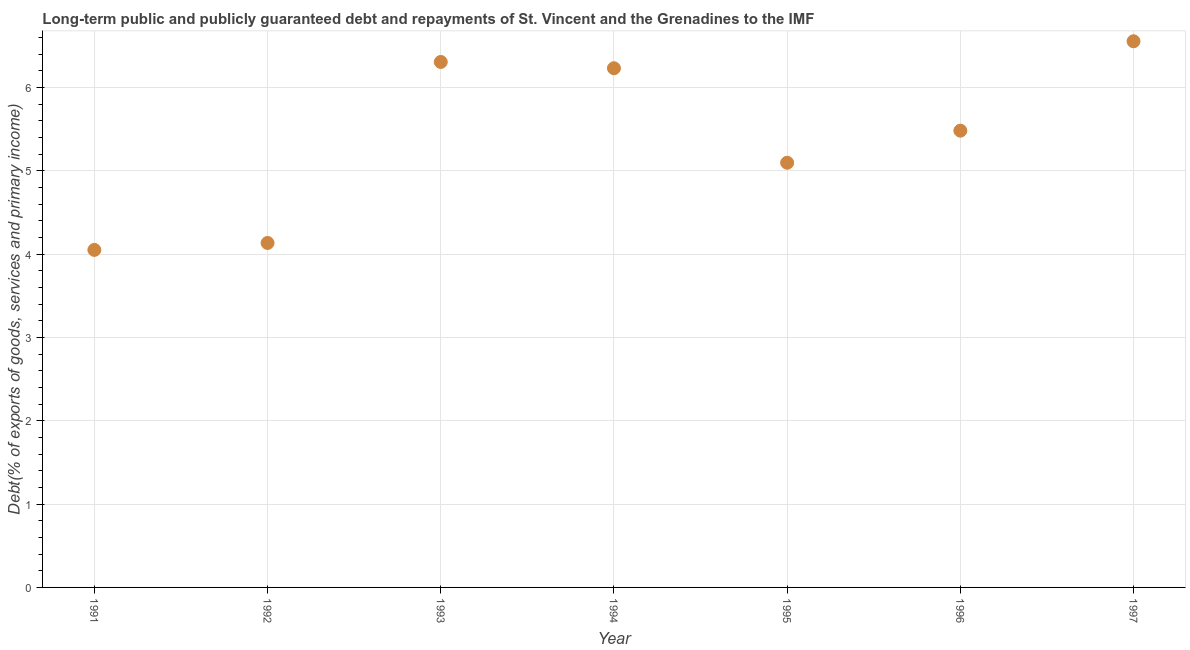What is the debt service in 1992?
Provide a succinct answer. 4.13. Across all years, what is the maximum debt service?
Provide a short and direct response. 6.55. Across all years, what is the minimum debt service?
Your answer should be compact. 4.05. In which year was the debt service maximum?
Provide a succinct answer. 1997. In which year was the debt service minimum?
Ensure brevity in your answer.  1991. What is the sum of the debt service?
Provide a succinct answer. 37.85. What is the difference between the debt service in 1994 and 1995?
Your response must be concise. 1.13. What is the average debt service per year?
Provide a succinct answer. 5.41. What is the median debt service?
Ensure brevity in your answer.  5.48. In how many years, is the debt service greater than 6.4 %?
Your response must be concise. 1. What is the ratio of the debt service in 1994 to that in 1995?
Provide a succinct answer. 1.22. Is the debt service in 1996 less than that in 1997?
Offer a very short reply. Yes. Is the difference between the debt service in 1996 and 1997 greater than the difference between any two years?
Offer a very short reply. No. What is the difference between the highest and the second highest debt service?
Provide a short and direct response. 0.25. What is the difference between the highest and the lowest debt service?
Ensure brevity in your answer.  2.5. In how many years, is the debt service greater than the average debt service taken over all years?
Your answer should be very brief. 4. Does the debt service monotonically increase over the years?
Keep it short and to the point. No. Are the values on the major ticks of Y-axis written in scientific E-notation?
Give a very brief answer. No. Does the graph contain any zero values?
Ensure brevity in your answer.  No. Does the graph contain grids?
Make the answer very short. Yes. What is the title of the graph?
Provide a succinct answer. Long-term public and publicly guaranteed debt and repayments of St. Vincent and the Grenadines to the IMF. What is the label or title of the Y-axis?
Provide a short and direct response. Debt(% of exports of goods, services and primary income). What is the Debt(% of exports of goods, services and primary income) in 1991?
Provide a succinct answer. 4.05. What is the Debt(% of exports of goods, services and primary income) in 1992?
Your answer should be very brief. 4.13. What is the Debt(% of exports of goods, services and primary income) in 1993?
Offer a very short reply. 6.31. What is the Debt(% of exports of goods, services and primary income) in 1994?
Offer a terse response. 6.23. What is the Debt(% of exports of goods, services and primary income) in 1995?
Your response must be concise. 5.1. What is the Debt(% of exports of goods, services and primary income) in 1996?
Your answer should be compact. 5.48. What is the Debt(% of exports of goods, services and primary income) in 1997?
Your answer should be compact. 6.55. What is the difference between the Debt(% of exports of goods, services and primary income) in 1991 and 1992?
Your answer should be compact. -0.08. What is the difference between the Debt(% of exports of goods, services and primary income) in 1991 and 1993?
Offer a terse response. -2.26. What is the difference between the Debt(% of exports of goods, services and primary income) in 1991 and 1994?
Provide a short and direct response. -2.18. What is the difference between the Debt(% of exports of goods, services and primary income) in 1991 and 1995?
Make the answer very short. -1.05. What is the difference between the Debt(% of exports of goods, services and primary income) in 1991 and 1996?
Keep it short and to the point. -1.43. What is the difference between the Debt(% of exports of goods, services and primary income) in 1991 and 1997?
Ensure brevity in your answer.  -2.5. What is the difference between the Debt(% of exports of goods, services and primary income) in 1992 and 1993?
Your answer should be very brief. -2.17. What is the difference between the Debt(% of exports of goods, services and primary income) in 1992 and 1994?
Provide a short and direct response. -2.1. What is the difference between the Debt(% of exports of goods, services and primary income) in 1992 and 1995?
Ensure brevity in your answer.  -0.96. What is the difference between the Debt(% of exports of goods, services and primary income) in 1992 and 1996?
Offer a very short reply. -1.35. What is the difference between the Debt(% of exports of goods, services and primary income) in 1992 and 1997?
Offer a very short reply. -2.42. What is the difference between the Debt(% of exports of goods, services and primary income) in 1993 and 1994?
Ensure brevity in your answer.  0.08. What is the difference between the Debt(% of exports of goods, services and primary income) in 1993 and 1995?
Keep it short and to the point. 1.21. What is the difference between the Debt(% of exports of goods, services and primary income) in 1993 and 1996?
Your answer should be compact. 0.82. What is the difference between the Debt(% of exports of goods, services and primary income) in 1993 and 1997?
Ensure brevity in your answer.  -0.25. What is the difference between the Debt(% of exports of goods, services and primary income) in 1994 and 1995?
Your response must be concise. 1.13. What is the difference between the Debt(% of exports of goods, services and primary income) in 1994 and 1996?
Keep it short and to the point. 0.75. What is the difference between the Debt(% of exports of goods, services and primary income) in 1994 and 1997?
Offer a very short reply. -0.32. What is the difference between the Debt(% of exports of goods, services and primary income) in 1995 and 1996?
Keep it short and to the point. -0.38. What is the difference between the Debt(% of exports of goods, services and primary income) in 1995 and 1997?
Make the answer very short. -1.46. What is the difference between the Debt(% of exports of goods, services and primary income) in 1996 and 1997?
Provide a succinct answer. -1.07. What is the ratio of the Debt(% of exports of goods, services and primary income) in 1991 to that in 1993?
Ensure brevity in your answer.  0.64. What is the ratio of the Debt(% of exports of goods, services and primary income) in 1991 to that in 1994?
Provide a succinct answer. 0.65. What is the ratio of the Debt(% of exports of goods, services and primary income) in 1991 to that in 1995?
Make the answer very short. 0.8. What is the ratio of the Debt(% of exports of goods, services and primary income) in 1991 to that in 1996?
Give a very brief answer. 0.74. What is the ratio of the Debt(% of exports of goods, services and primary income) in 1991 to that in 1997?
Ensure brevity in your answer.  0.62. What is the ratio of the Debt(% of exports of goods, services and primary income) in 1992 to that in 1993?
Offer a terse response. 0.66. What is the ratio of the Debt(% of exports of goods, services and primary income) in 1992 to that in 1994?
Your answer should be very brief. 0.66. What is the ratio of the Debt(% of exports of goods, services and primary income) in 1992 to that in 1995?
Make the answer very short. 0.81. What is the ratio of the Debt(% of exports of goods, services and primary income) in 1992 to that in 1996?
Ensure brevity in your answer.  0.75. What is the ratio of the Debt(% of exports of goods, services and primary income) in 1992 to that in 1997?
Ensure brevity in your answer.  0.63. What is the ratio of the Debt(% of exports of goods, services and primary income) in 1993 to that in 1994?
Offer a very short reply. 1.01. What is the ratio of the Debt(% of exports of goods, services and primary income) in 1993 to that in 1995?
Your answer should be compact. 1.24. What is the ratio of the Debt(% of exports of goods, services and primary income) in 1993 to that in 1996?
Offer a very short reply. 1.15. What is the ratio of the Debt(% of exports of goods, services and primary income) in 1993 to that in 1997?
Your response must be concise. 0.96. What is the ratio of the Debt(% of exports of goods, services and primary income) in 1994 to that in 1995?
Offer a very short reply. 1.22. What is the ratio of the Debt(% of exports of goods, services and primary income) in 1994 to that in 1996?
Your answer should be very brief. 1.14. What is the ratio of the Debt(% of exports of goods, services and primary income) in 1994 to that in 1997?
Make the answer very short. 0.95. What is the ratio of the Debt(% of exports of goods, services and primary income) in 1995 to that in 1996?
Offer a very short reply. 0.93. What is the ratio of the Debt(% of exports of goods, services and primary income) in 1995 to that in 1997?
Provide a short and direct response. 0.78. What is the ratio of the Debt(% of exports of goods, services and primary income) in 1996 to that in 1997?
Make the answer very short. 0.84. 